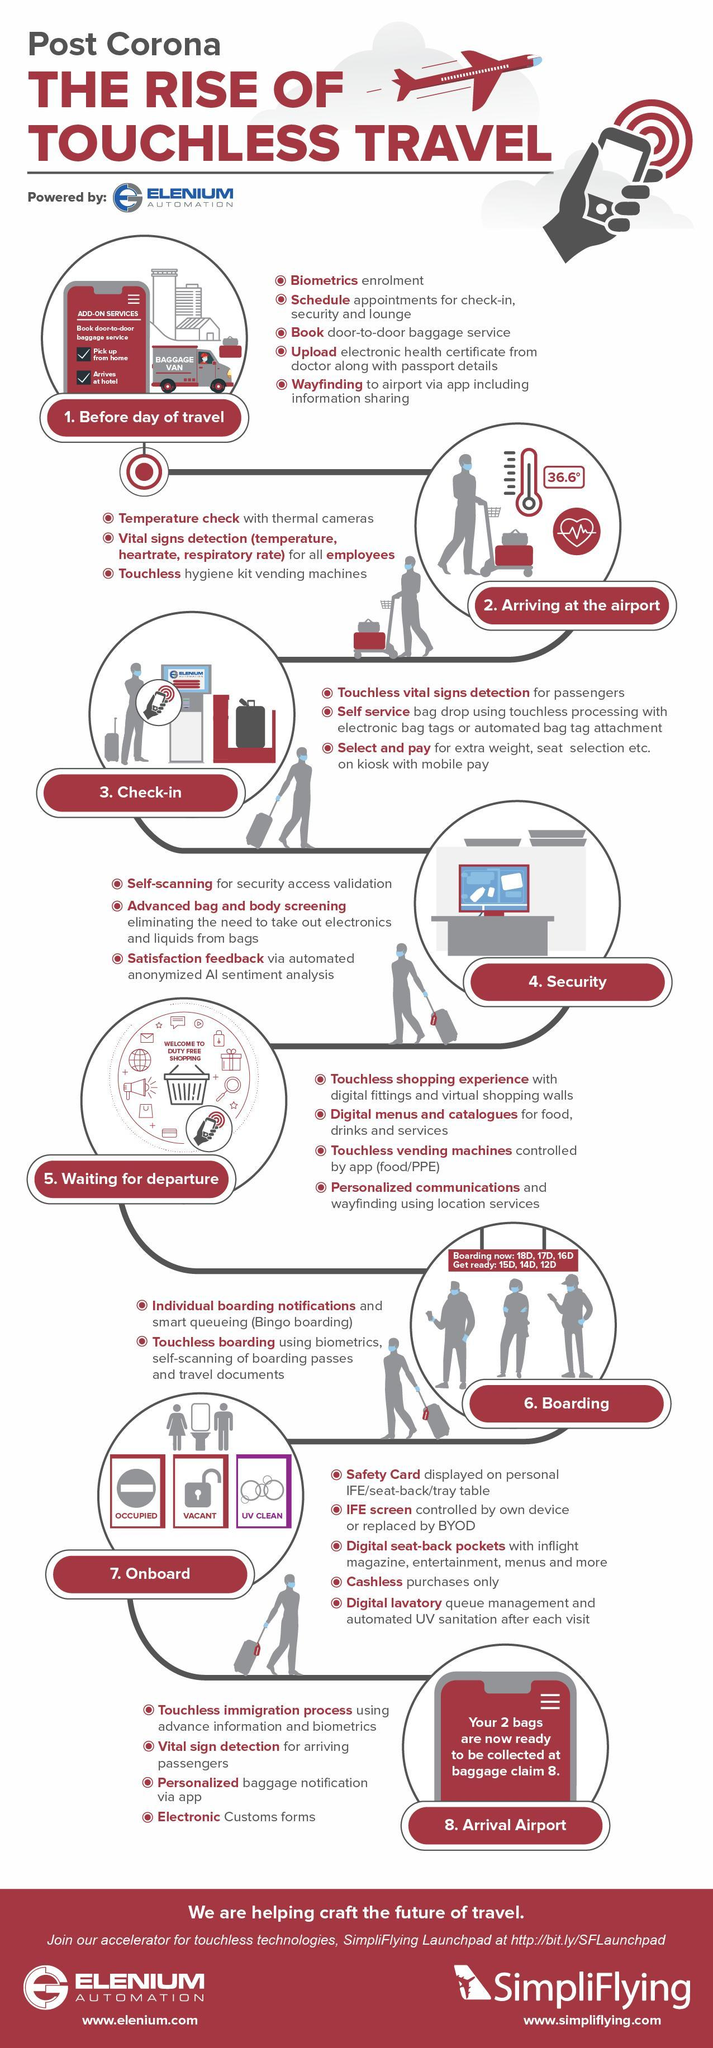What is the number of procedures during security checking?
Answer the question with a short phrase. 3 What is the number of procedures after arriving at the airport? 3 What is the number of procedures during check-in? 3 